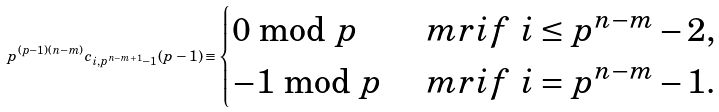Convert formula to latex. <formula><loc_0><loc_0><loc_500><loc_500>p ^ { ( p - 1 ) ( n - m ) } c _ { i , p ^ { n - m + 1 } - 1 } ( p - 1 ) \equiv \begin{cases} 0 \bmod p & \ m r { i f \ } i \leq p ^ { n - m } - 2 , \\ - 1 \bmod p & \ m r { i f \ } i = p ^ { n - m } - 1 . \end{cases}</formula> 